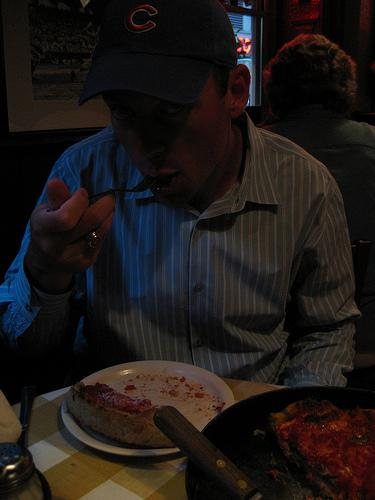Question: who is eating?
Choices:
A. The woman.
B. The man.
C. The boy.
D. The girl.
Answer with the letter. Answer: B Question: when is the picture taken?
Choices:
A. Morning.
B. Afternoon.
C. Midnight.
D. Evening.
Answer with the letter. Answer: D Question: why is there a plate?
Choices:
A. For eating.
B. For serving.
C. For guests.
D. Hold food.
Answer with the letter. Answer: D Question: what is on the plate?
Choices:
A. Italian food.
B. Slice.
C. Pizza.
D. Pepperoni and cheese slice.
Answer with the letter. Answer: C 